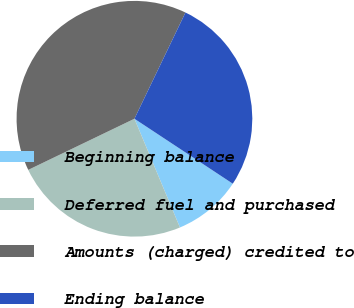Convert chart to OTSL. <chart><loc_0><loc_0><loc_500><loc_500><pie_chart><fcel>Beginning balance<fcel>Deferred fuel and purchased<fcel>Amounts (charged) credited to<fcel>Ending balance<nl><fcel>9.4%<fcel>24.17%<fcel>39.27%<fcel>27.16%<nl></chart> 